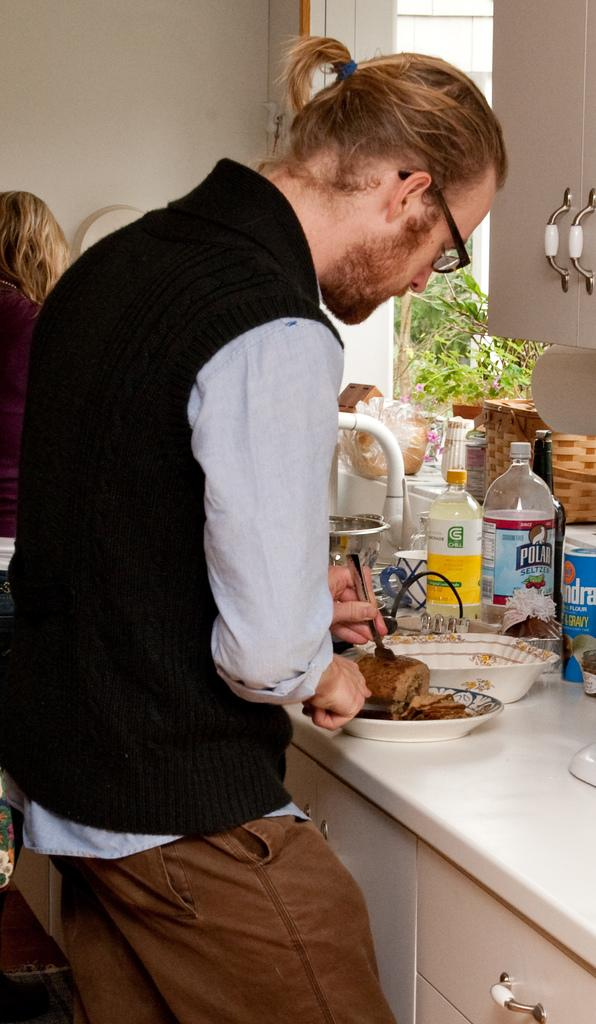<image>
Offer a succinct explanation of the picture presented. A man cuts food at a counter that also has a bottle of Polar Seltzer and Chill Lemonade on it. 